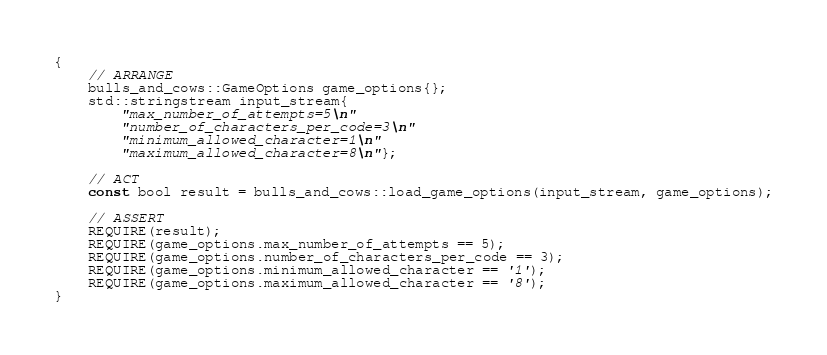Convert code to text. <code><loc_0><loc_0><loc_500><loc_500><_C++_>{
    // ARRANGE
    bulls_and_cows::GameOptions game_options{};
    std::stringstream input_stream{
        "max_number_of_attempts=5\n"
        "number_of_characters_per_code=3\n"
        "minimum_allowed_character=1\n"
        "maximum_allowed_character=8\n"};

    // ACT
    const bool result = bulls_and_cows::load_game_options(input_stream, game_options);

    // ASSERT
    REQUIRE(result);
    REQUIRE(game_options.max_number_of_attempts == 5);
    REQUIRE(game_options.number_of_characters_per_code == 3);
    REQUIRE(game_options.minimum_allowed_character == '1');
    REQUIRE(game_options.maximum_allowed_character == '8');
}


</code> 